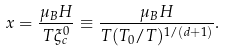<formula> <loc_0><loc_0><loc_500><loc_500>x = \frac { \mu _ { B } H } { T \xi _ { c } ^ { 0 } } \equiv \frac { \mu _ { B } H } { T ( T _ { 0 } / T ) ^ { 1 / ( d + 1 ) } } .</formula> 